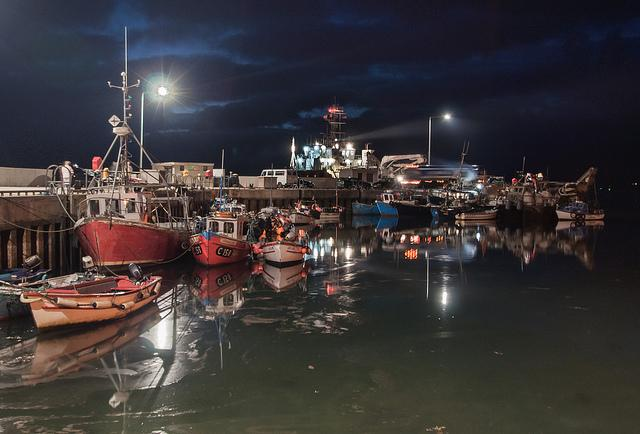What do the small floats on the boats sides here meant to prevent the boats doing? bumping 